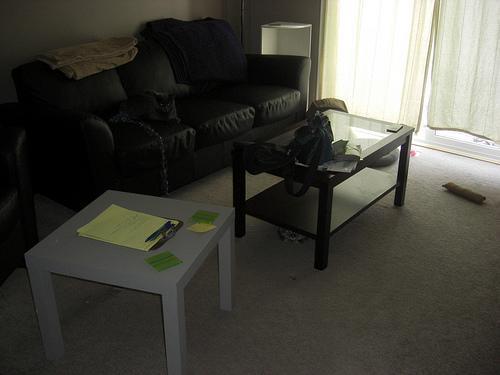How many tables are there?
Give a very brief answer. 2. 